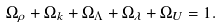<formula> <loc_0><loc_0><loc_500><loc_500>\Omega _ { \rho } + \Omega _ { k } + \Omega _ { \Lambda } + \Omega _ { \lambda } + \Omega _ { U } = 1 .</formula> 